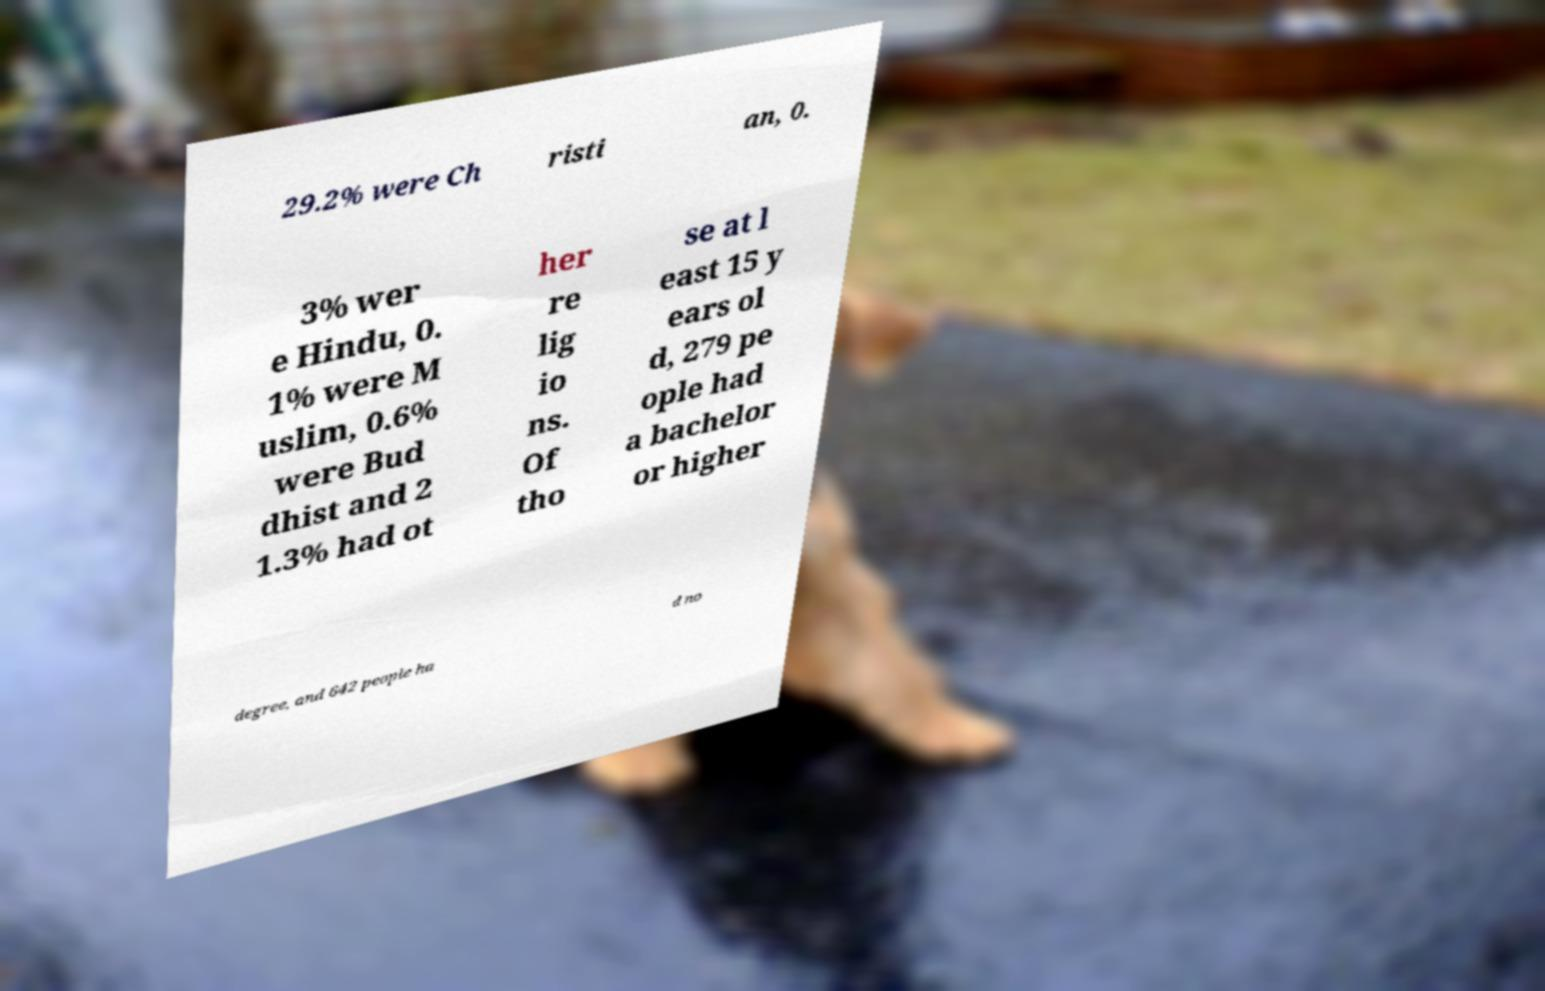Could you assist in decoding the text presented in this image and type it out clearly? 29.2% were Ch risti an, 0. 3% wer e Hindu, 0. 1% were M uslim, 0.6% were Bud dhist and 2 1.3% had ot her re lig io ns. Of tho se at l east 15 y ears ol d, 279 pe ople had a bachelor or higher degree, and 642 people ha d no 